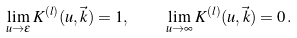<formula> <loc_0><loc_0><loc_500><loc_500>\lim _ { u \rightarrow \epsilon } K ^ { ( l ) } ( u , \vec { k } ) = 1 , \quad \lim _ { u \rightarrow \infty } K ^ { ( l ) } ( u , \vec { k } ) = 0 \, .</formula> 